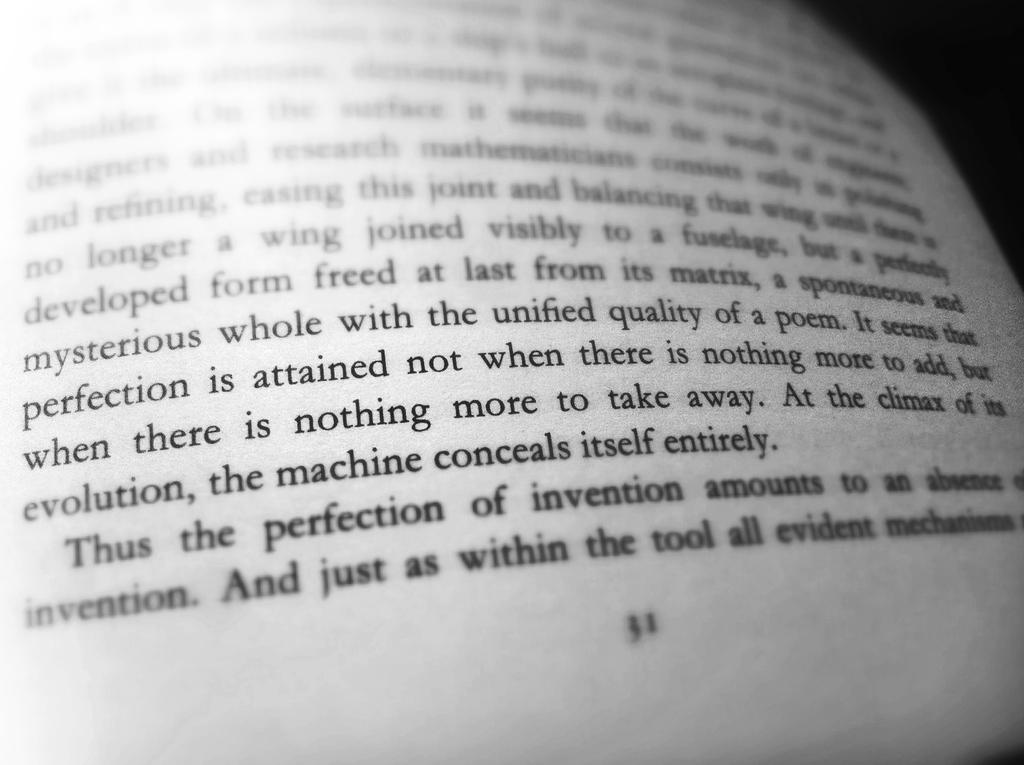<image>
Render a clear and concise summary of the photo. The page of this book finishes with the sentence And just as within the tool all evident. 